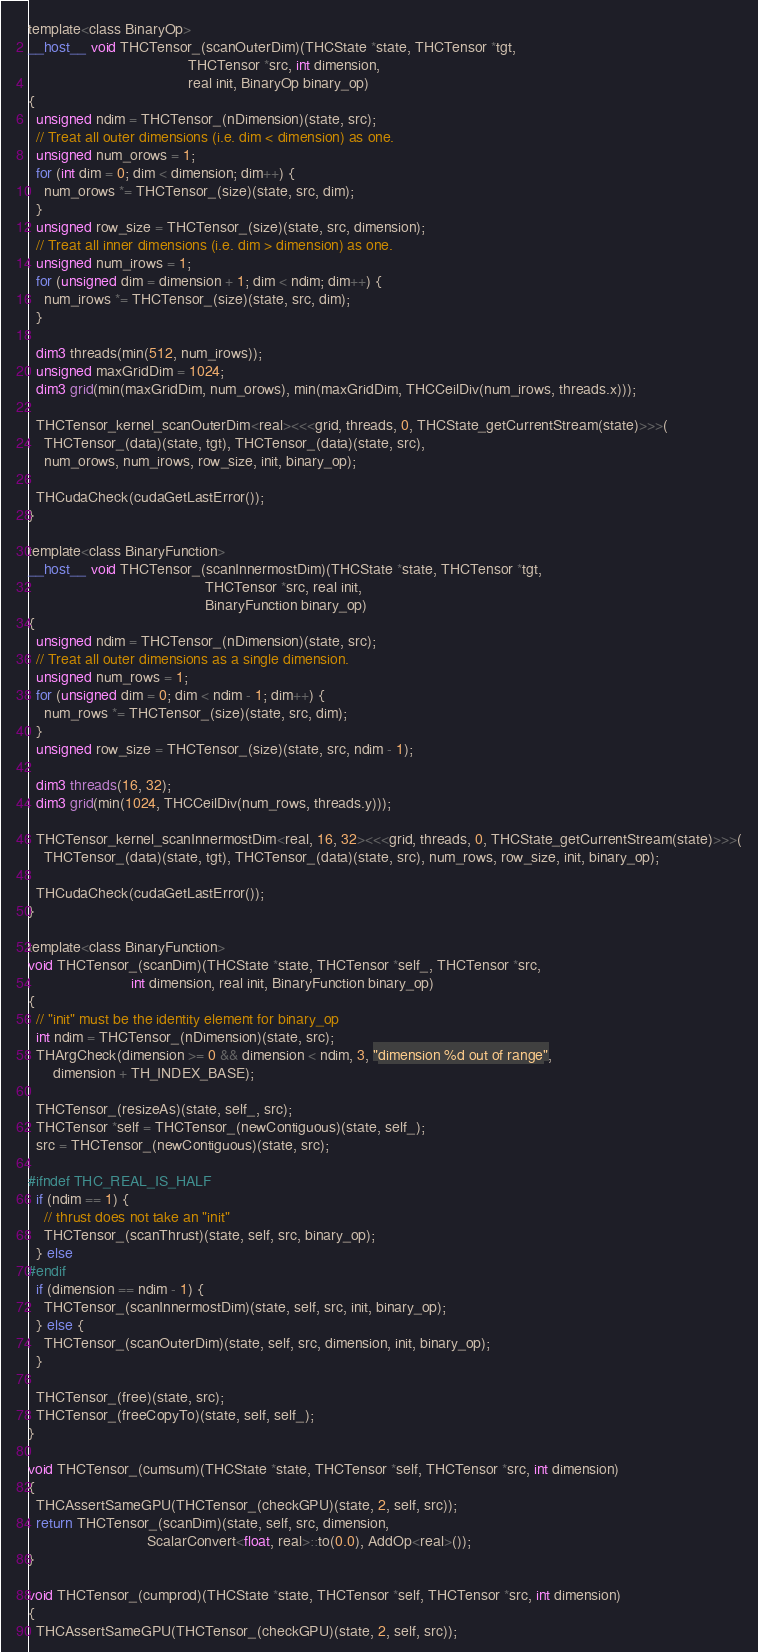<code> <loc_0><loc_0><loc_500><loc_500><_Cuda_>
template<class BinaryOp>
__host__ void THCTensor_(scanOuterDim)(THCState *state, THCTensor *tgt,
                                       THCTensor *src, int dimension,
                                       real init, BinaryOp binary_op)
{
  unsigned ndim = THCTensor_(nDimension)(state, src);
  // Treat all outer dimensions (i.e. dim < dimension) as one.
  unsigned num_orows = 1;
  for (int dim = 0; dim < dimension; dim++) {
    num_orows *= THCTensor_(size)(state, src, dim);
  }
  unsigned row_size = THCTensor_(size)(state, src, dimension);
  // Treat all inner dimensions (i.e. dim > dimension) as one.
  unsigned num_irows = 1;
  for (unsigned dim = dimension + 1; dim < ndim; dim++) {
    num_irows *= THCTensor_(size)(state, src, dim);
  }

  dim3 threads(min(512, num_irows));
  unsigned maxGridDim = 1024;
  dim3 grid(min(maxGridDim, num_orows), min(maxGridDim, THCCeilDiv(num_irows, threads.x)));

  THCTensor_kernel_scanOuterDim<real><<<grid, threads, 0, THCState_getCurrentStream(state)>>>(
    THCTensor_(data)(state, tgt), THCTensor_(data)(state, src),
    num_orows, num_irows, row_size, init, binary_op);

  THCudaCheck(cudaGetLastError());
}

template<class BinaryFunction>
__host__ void THCTensor_(scanInnermostDim)(THCState *state, THCTensor *tgt,
                                           THCTensor *src, real init,
                                           BinaryFunction binary_op)
{
  unsigned ndim = THCTensor_(nDimension)(state, src);
  // Treat all outer dimensions as a single dimension.
  unsigned num_rows = 1;
  for (unsigned dim = 0; dim < ndim - 1; dim++) {
    num_rows *= THCTensor_(size)(state, src, dim);
  }
  unsigned row_size = THCTensor_(size)(state, src, ndim - 1);

  dim3 threads(16, 32);
  dim3 grid(min(1024, THCCeilDiv(num_rows, threads.y)));

  THCTensor_kernel_scanInnermostDim<real, 16, 32><<<grid, threads, 0, THCState_getCurrentStream(state)>>>(
    THCTensor_(data)(state, tgt), THCTensor_(data)(state, src), num_rows, row_size, init, binary_op);

  THCudaCheck(cudaGetLastError());
}

template<class BinaryFunction>
void THCTensor_(scanDim)(THCState *state, THCTensor *self_, THCTensor *src,
                         int dimension, real init, BinaryFunction binary_op)
{
  // "init" must be the identity element for binary_op
  int ndim = THCTensor_(nDimension)(state, src);
  THArgCheck(dimension >= 0 && dimension < ndim, 3, "dimension %d out of range",
      dimension + TH_INDEX_BASE);

  THCTensor_(resizeAs)(state, self_, src);
  THCTensor *self = THCTensor_(newContiguous)(state, self_);
  src = THCTensor_(newContiguous)(state, src);

#ifndef THC_REAL_IS_HALF
  if (ndim == 1) {
    // thrust does not take an "init"
    THCTensor_(scanThrust)(state, self, src, binary_op);
  } else
#endif
  if (dimension == ndim - 1) {
    THCTensor_(scanInnermostDim)(state, self, src, init, binary_op);
  } else {
    THCTensor_(scanOuterDim)(state, self, src, dimension, init, binary_op);
  }

  THCTensor_(free)(state, src);
  THCTensor_(freeCopyTo)(state, self, self_);
}

void THCTensor_(cumsum)(THCState *state, THCTensor *self, THCTensor *src, int dimension)
{
  THCAssertSameGPU(THCTensor_(checkGPU)(state, 2, self, src));
  return THCTensor_(scanDim)(state, self, src, dimension,
                             ScalarConvert<float, real>::to(0.0), AddOp<real>());
}

void THCTensor_(cumprod)(THCState *state, THCTensor *self, THCTensor *src, int dimension)
{
  THCAssertSameGPU(THCTensor_(checkGPU)(state, 2, self, src));</code> 